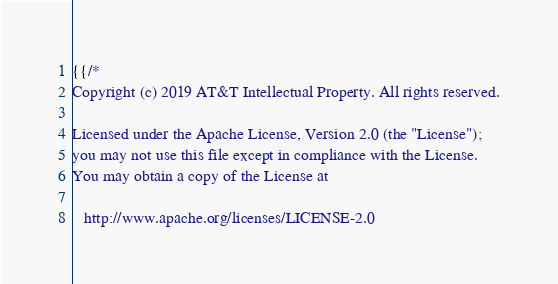<code> <loc_0><loc_0><loc_500><loc_500><_YAML_>{{/*
Copyright (c) 2019 AT&T Intellectual Property. All rights reserved.

Licensed under the Apache License, Version 2.0 (the "License");
you may not use this file except in compliance with the License.
You may obtain a copy of the License at

   http://www.apache.org/licenses/LICENSE-2.0
</code> 